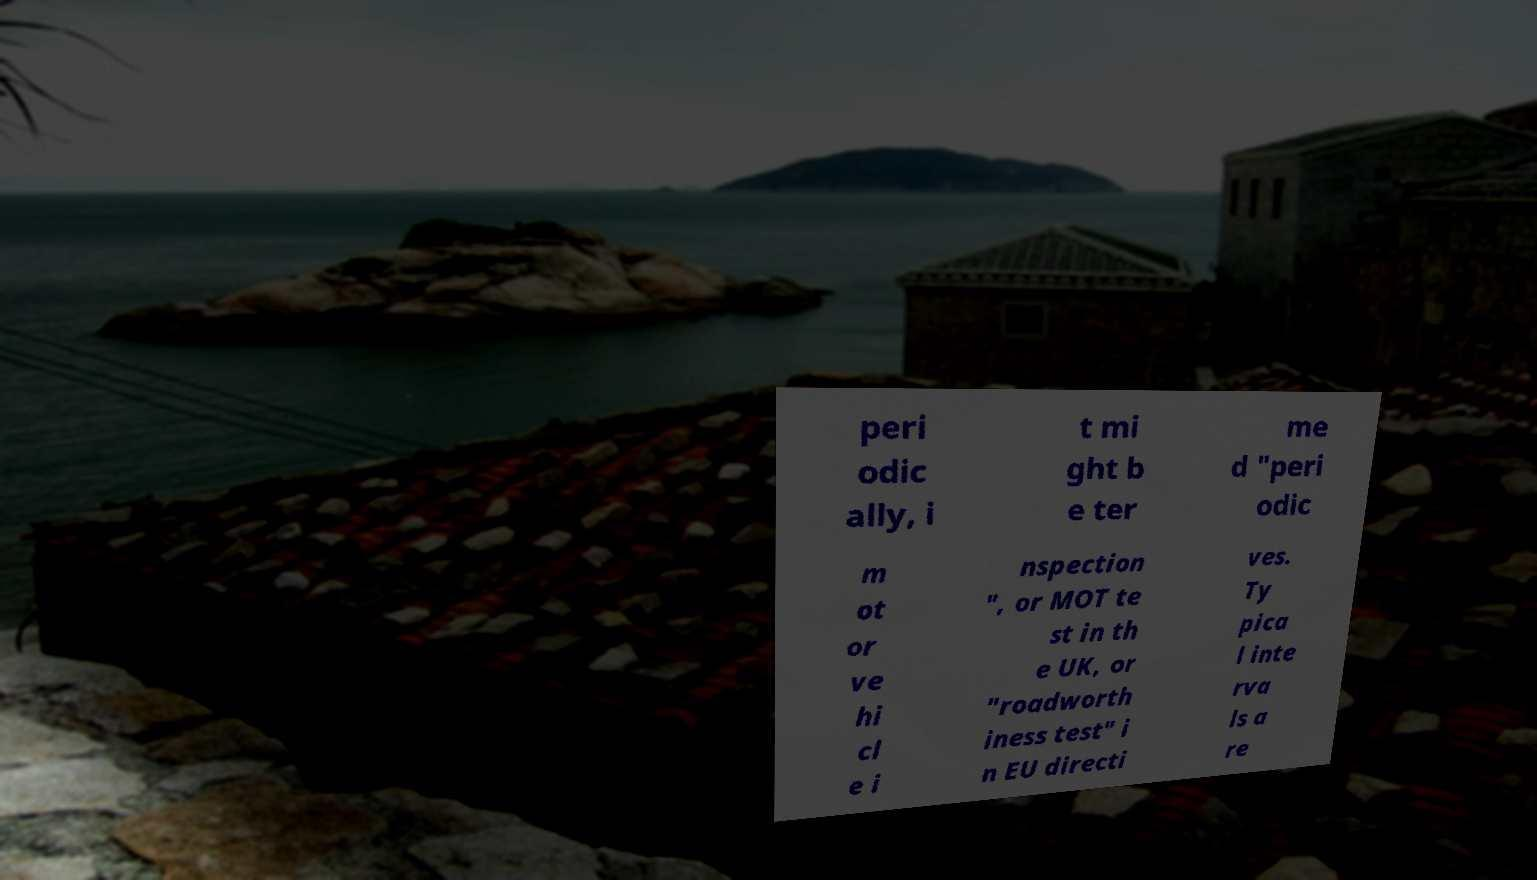What messages or text are displayed in this image? I need them in a readable, typed format. peri odic ally, i t mi ght b e ter me d "peri odic m ot or ve hi cl e i nspection ", or MOT te st in th e UK, or "roadworth iness test" i n EU directi ves. Ty pica l inte rva ls a re 